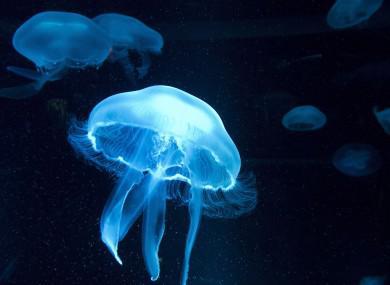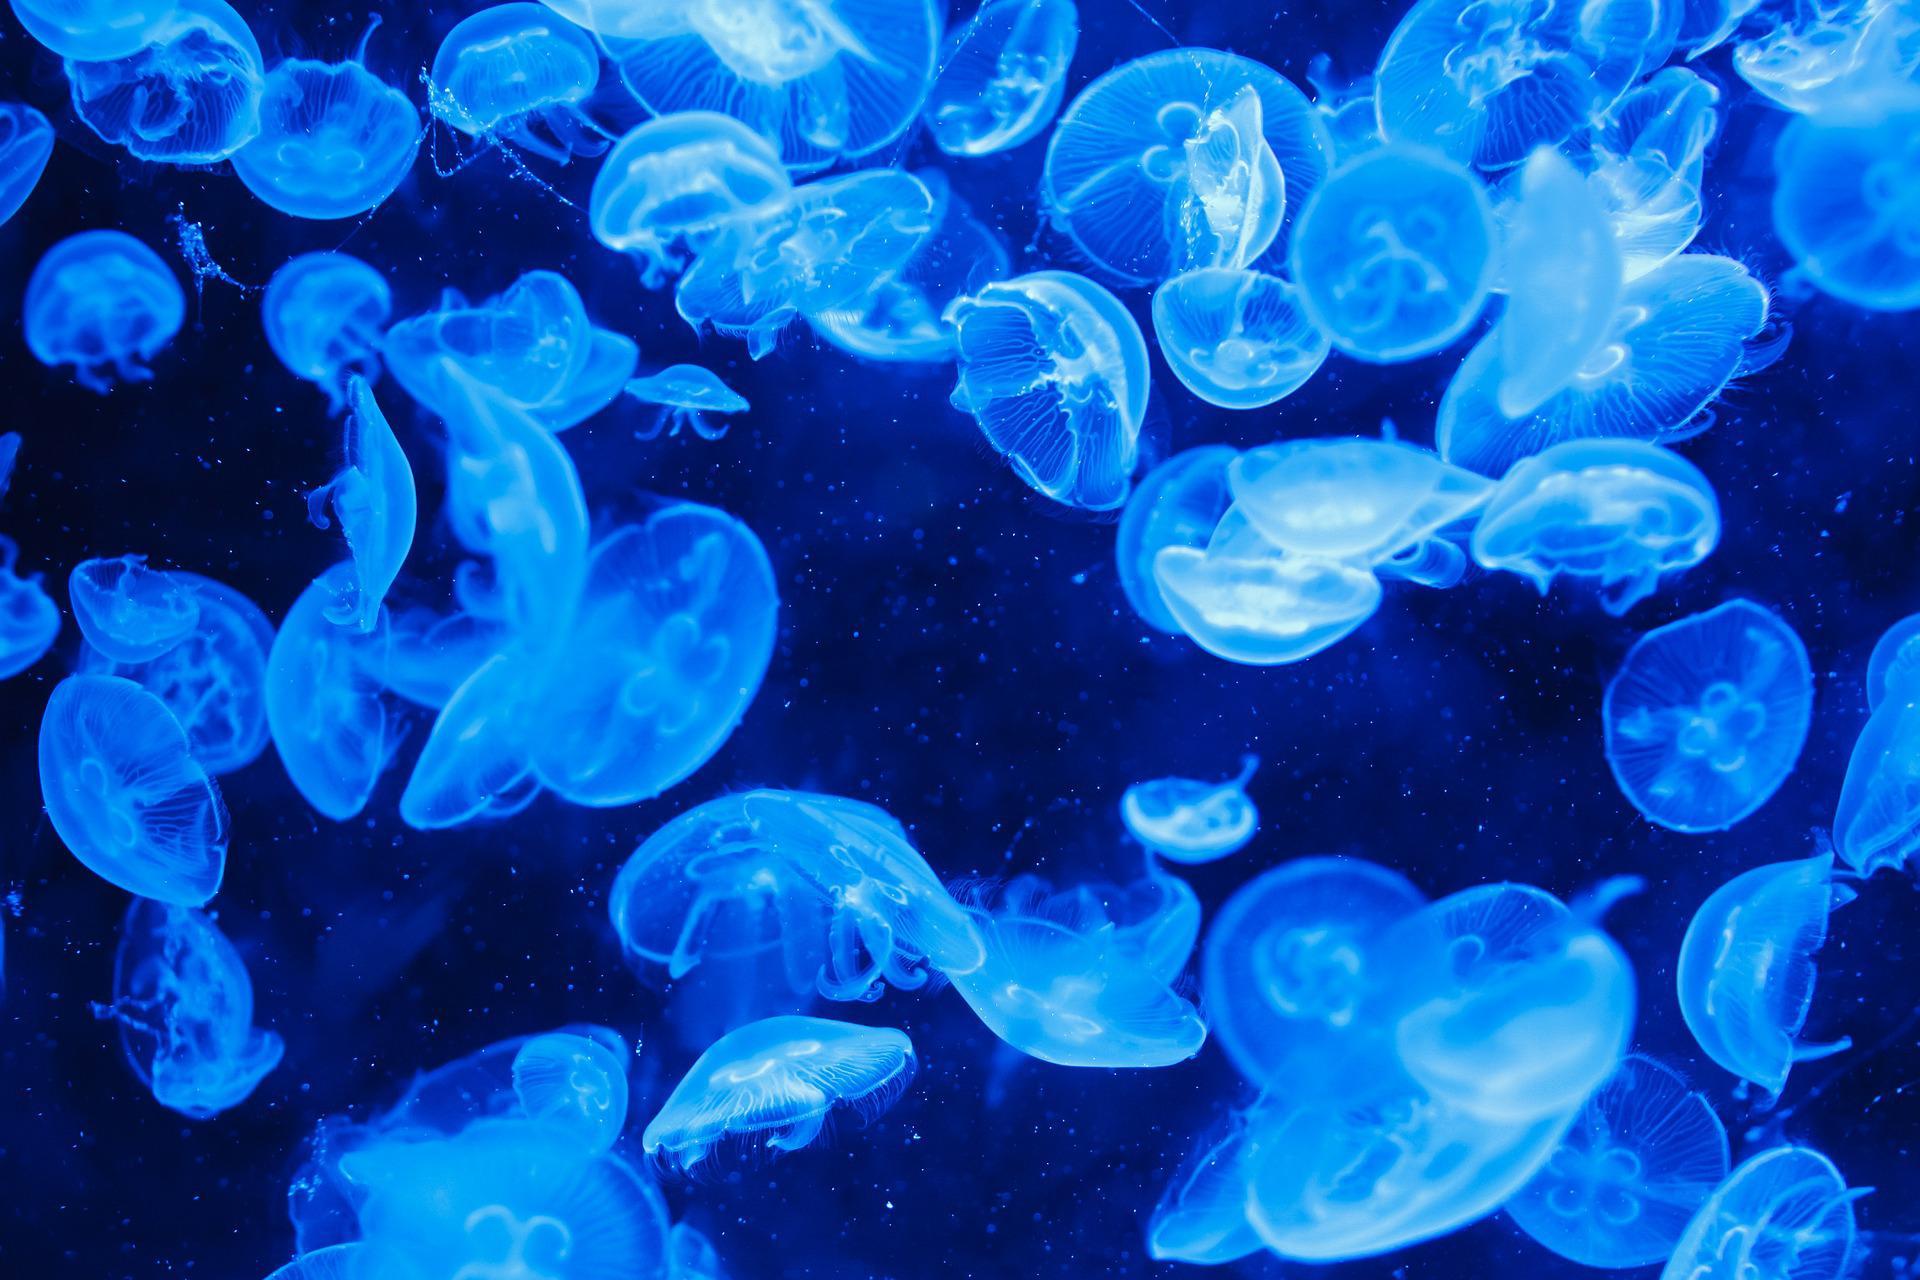The first image is the image on the left, the second image is the image on the right. Evaluate the accuracy of this statement regarding the images: "There are pink jellyfish in the image on the left.". Is it true? Answer yes or no. No. The first image is the image on the left, the second image is the image on the right. Analyze the images presented: Is the assertion "In one of the images, there are warm colored jellyfish" valid? Answer yes or no. No. 